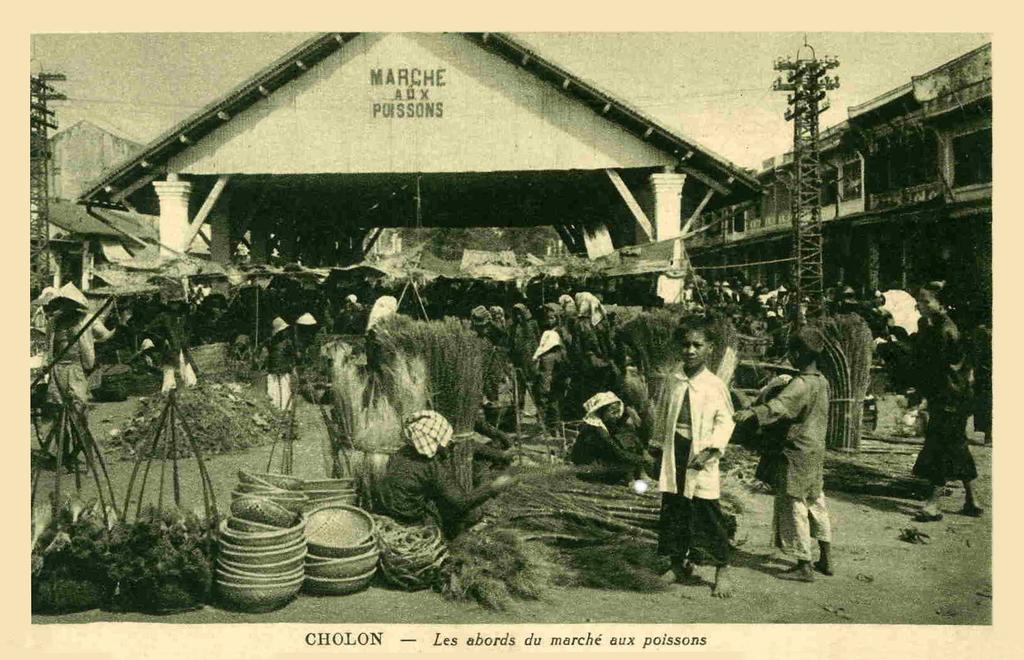What is the color scheme of the poster in the image? The poster is black and white. What type of structure can be seen in the image? There is a house in the image. What other structures are present in the image? There are buildings in the image. Are there any people in the image? Yes, there are persons in the image. What else can be seen in the image besides the structures and people? There are poles and other objects in the image. How many baskets can be seen in the image? There are no baskets present in the image. What type of calculator is being used by the person in the image? There is no calculator visible in the image, and no person is using one. 